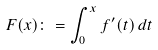Convert formula to latex. <formula><loc_0><loc_0><loc_500><loc_500>F ( x ) \colon = \int _ { 0 } ^ { x } f ^ { \prime } ( t ) \, d t</formula> 